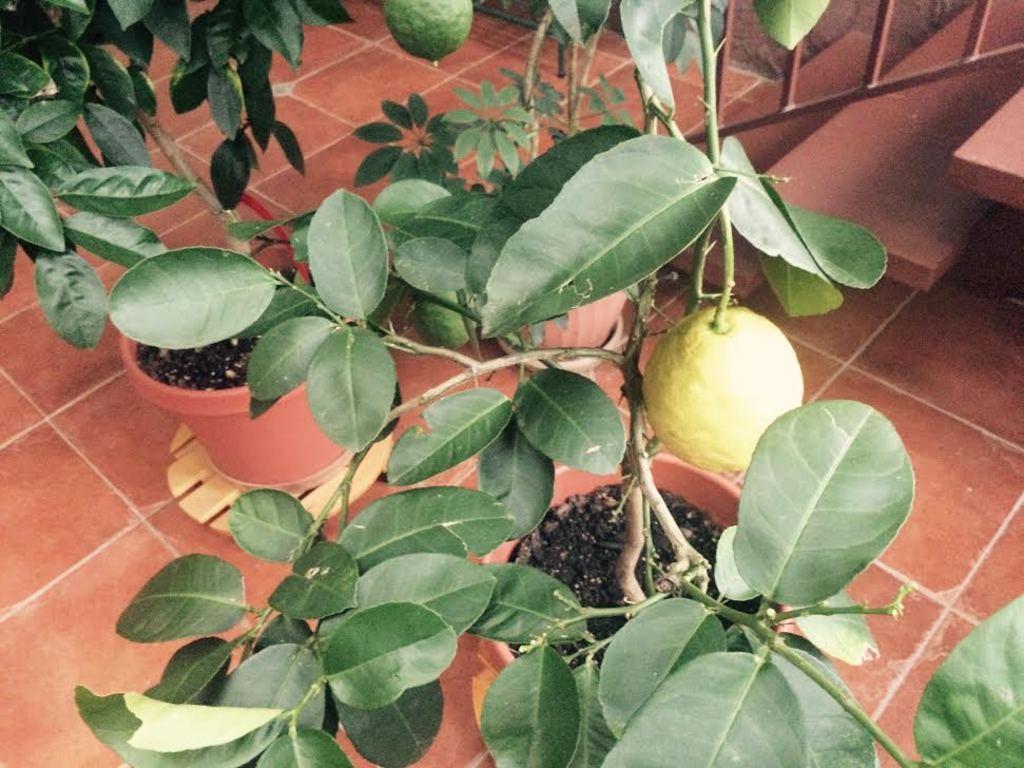How would you summarize this image in a sentence or two? In this image, we can see plants in the pots and there are fruits. At the bottom, there are stairs, railing and there is floor. 